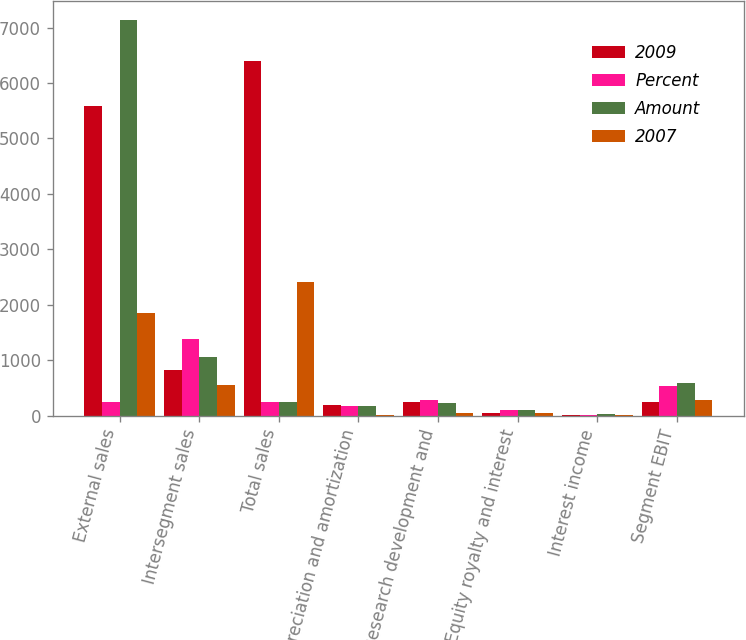<chart> <loc_0><loc_0><loc_500><loc_500><stacked_bar_chart><ecel><fcel>External sales<fcel>Intersegment sales<fcel>Total sales<fcel>Depreciation and amortization<fcel>Research development and<fcel>Equity royalty and interest<fcel>Interest income<fcel>Segment EBIT<nl><fcel>2009<fcel>5582<fcel>823<fcel>6405<fcel>185<fcel>241<fcel>54<fcel>3<fcel>252<nl><fcel>Percent<fcel>241<fcel>1378<fcel>241<fcel>180<fcel>286<fcel>99<fcel>10<fcel>535<nl><fcel>Amount<fcel>7129<fcel>1053<fcel>241<fcel>176<fcel>222<fcel>92<fcel>26<fcel>589<nl><fcel>2007<fcel>1850<fcel>555<fcel>2405<fcel>5<fcel>45<fcel>45<fcel>7<fcel>283<nl></chart> 